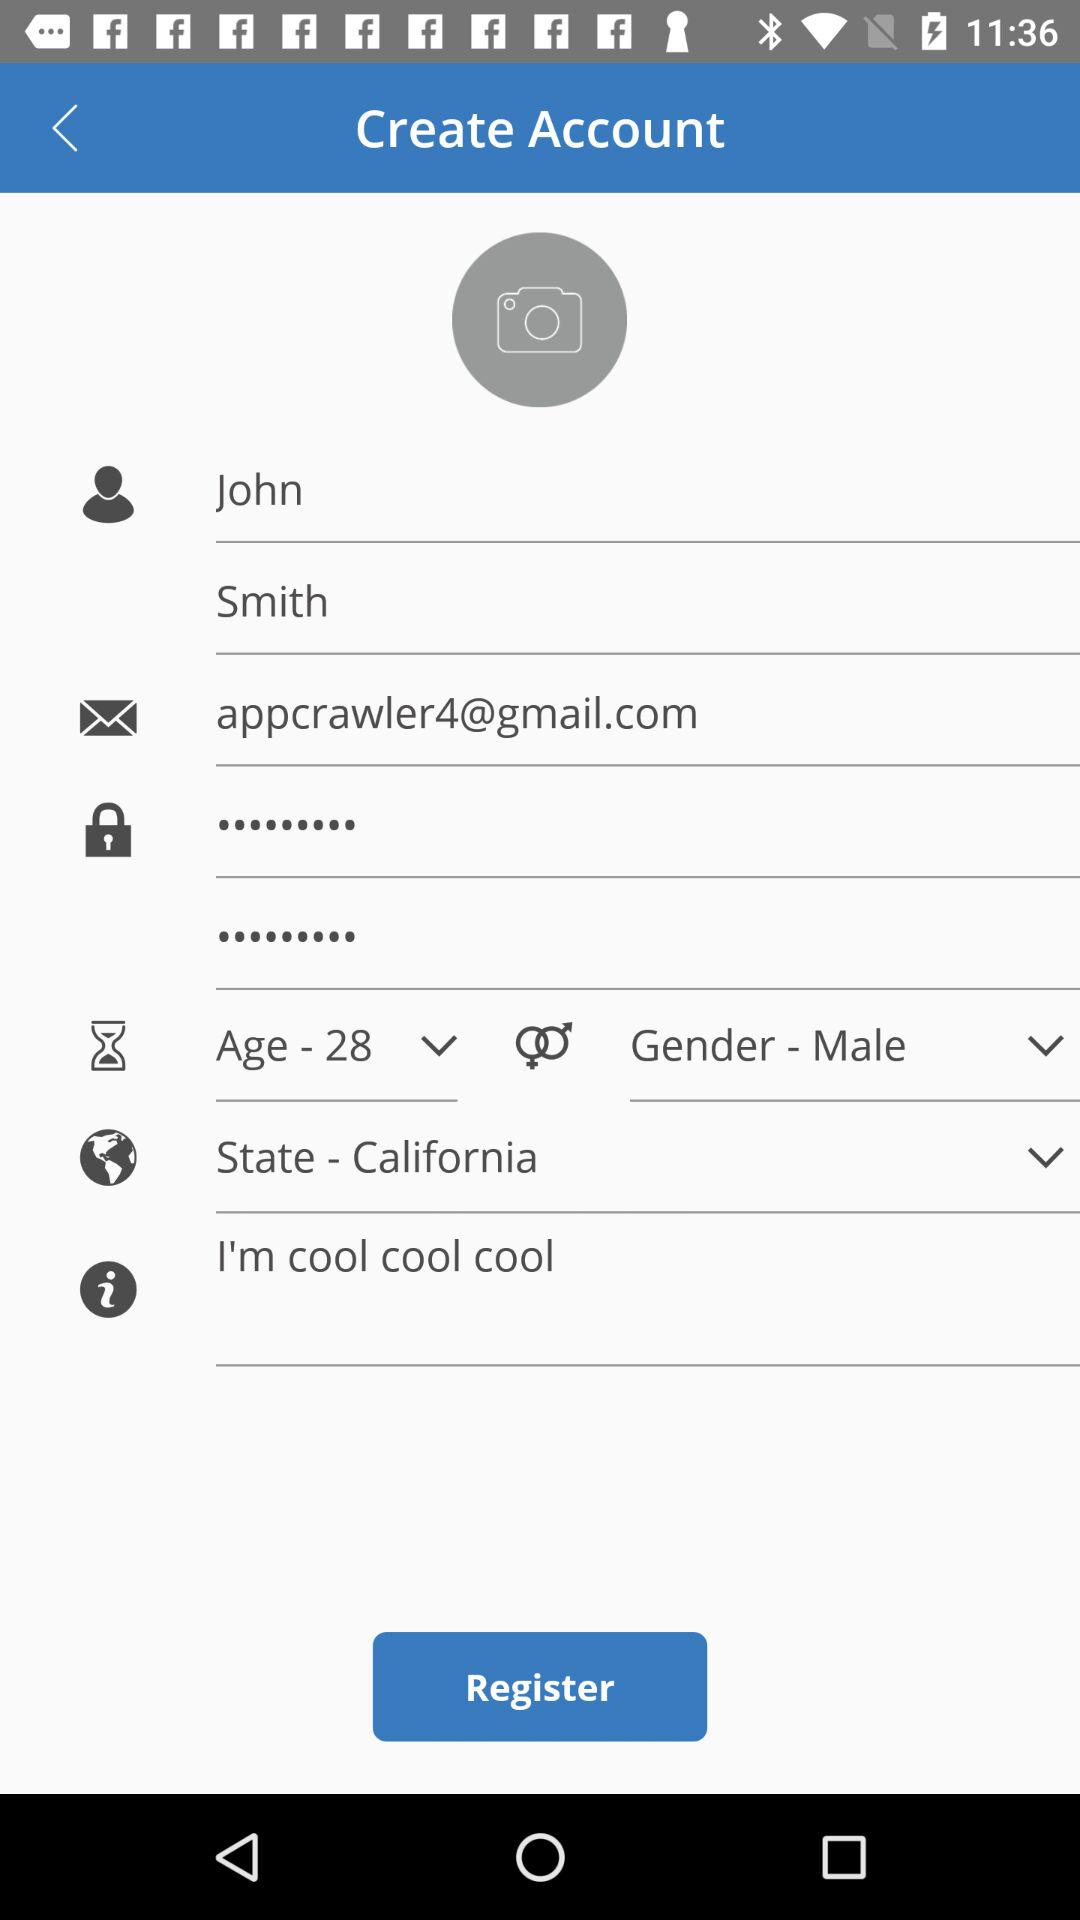What is the email address? The email address is appcrawler4@gmail.com. 